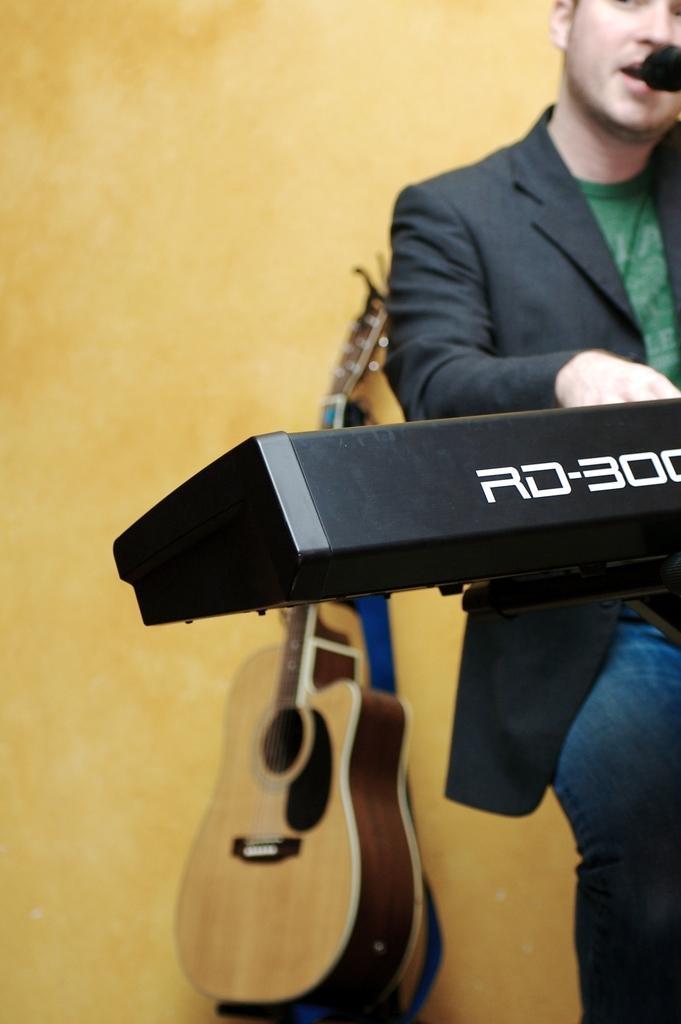Please provide a concise description of this image. Here is a man sitting and playing piano. He is singing a song. I can see a guitar which is kept aside at the background. 